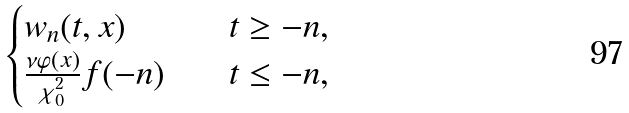Convert formula to latex. <formula><loc_0><loc_0><loc_500><loc_500>\begin{cases} w _ { n } ( t , x ) & \quad t \geq - n , \\ \frac { \nu \varphi ( x ) } { \chi _ { 0 } ^ { 2 } } f ( - n ) & \quad t \leq - n , \end{cases}</formula> 